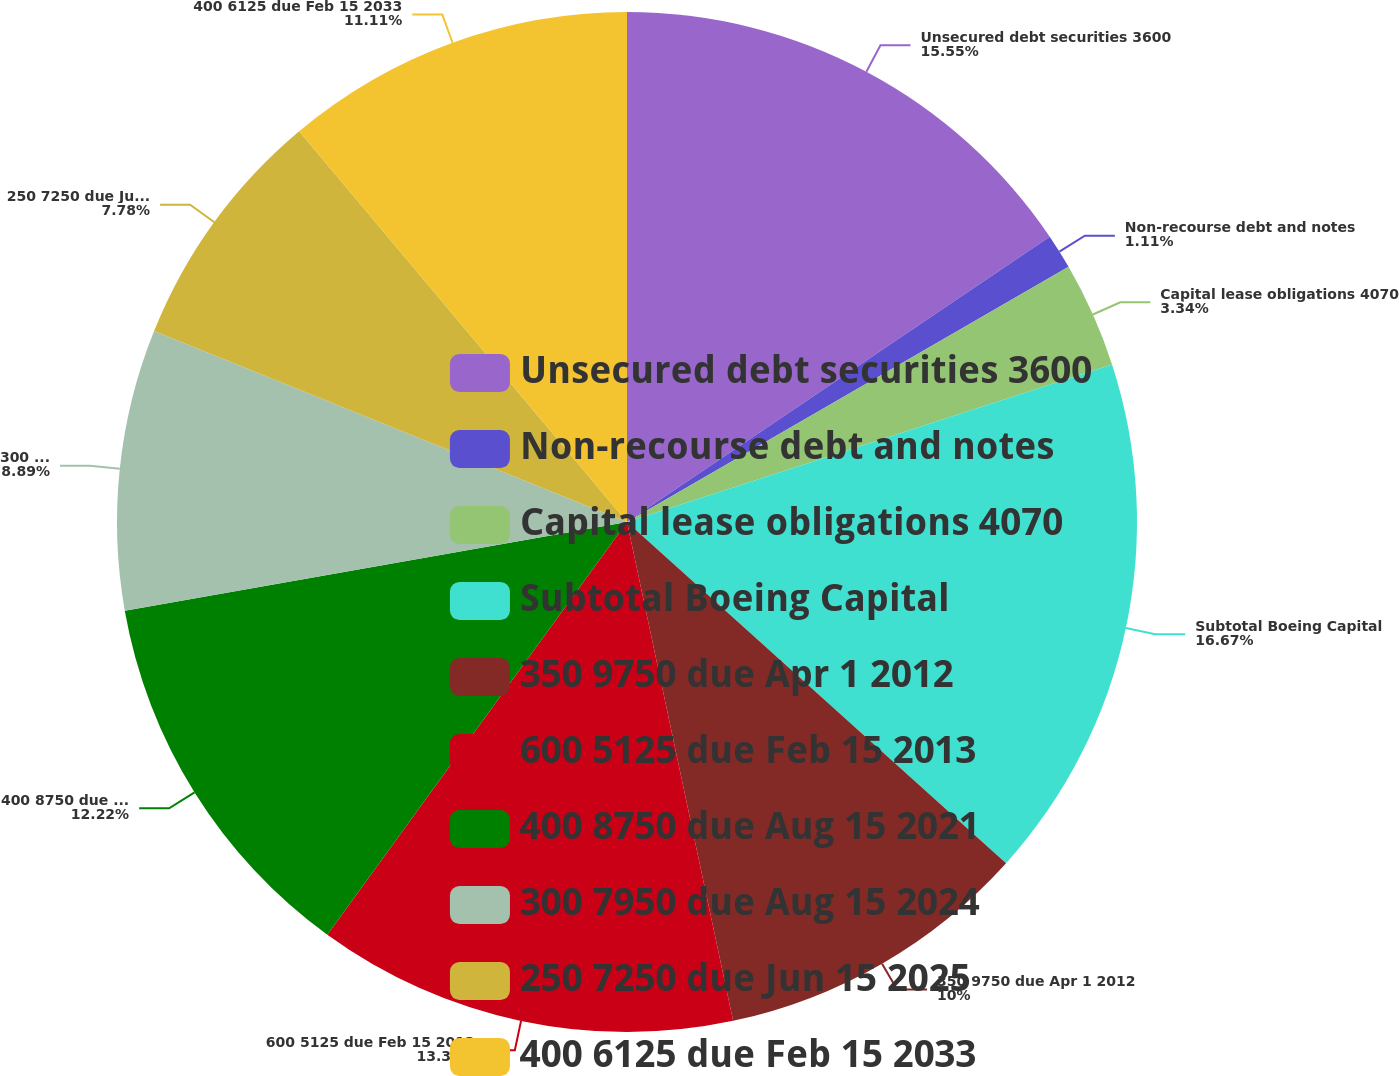Convert chart to OTSL. <chart><loc_0><loc_0><loc_500><loc_500><pie_chart><fcel>Unsecured debt securities 3600<fcel>Non-recourse debt and notes<fcel>Capital lease obligations 4070<fcel>Subtotal Boeing Capital<fcel>350 9750 due Apr 1 2012<fcel>600 5125 due Feb 15 2013<fcel>400 8750 due Aug 15 2021<fcel>300 7950 due Aug 15 2024<fcel>250 7250 due Jun 15 2025<fcel>400 6125 due Feb 15 2033<nl><fcel>15.55%<fcel>1.11%<fcel>3.34%<fcel>16.66%<fcel>10.0%<fcel>13.33%<fcel>12.22%<fcel>8.89%<fcel>7.78%<fcel>11.11%<nl></chart> 